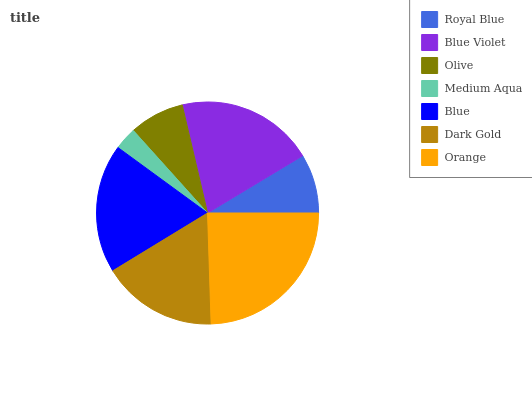Is Medium Aqua the minimum?
Answer yes or no. Yes. Is Orange the maximum?
Answer yes or no. Yes. Is Blue Violet the minimum?
Answer yes or no. No. Is Blue Violet the maximum?
Answer yes or no. No. Is Blue Violet greater than Royal Blue?
Answer yes or no. Yes. Is Royal Blue less than Blue Violet?
Answer yes or no. Yes. Is Royal Blue greater than Blue Violet?
Answer yes or no. No. Is Blue Violet less than Royal Blue?
Answer yes or no. No. Is Dark Gold the high median?
Answer yes or no. Yes. Is Dark Gold the low median?
Answer yes or no. Yes. Is Blue the high median?
Answer yes or no. No. Is Medium Aqua the low median?
Answer yes or no. No. 